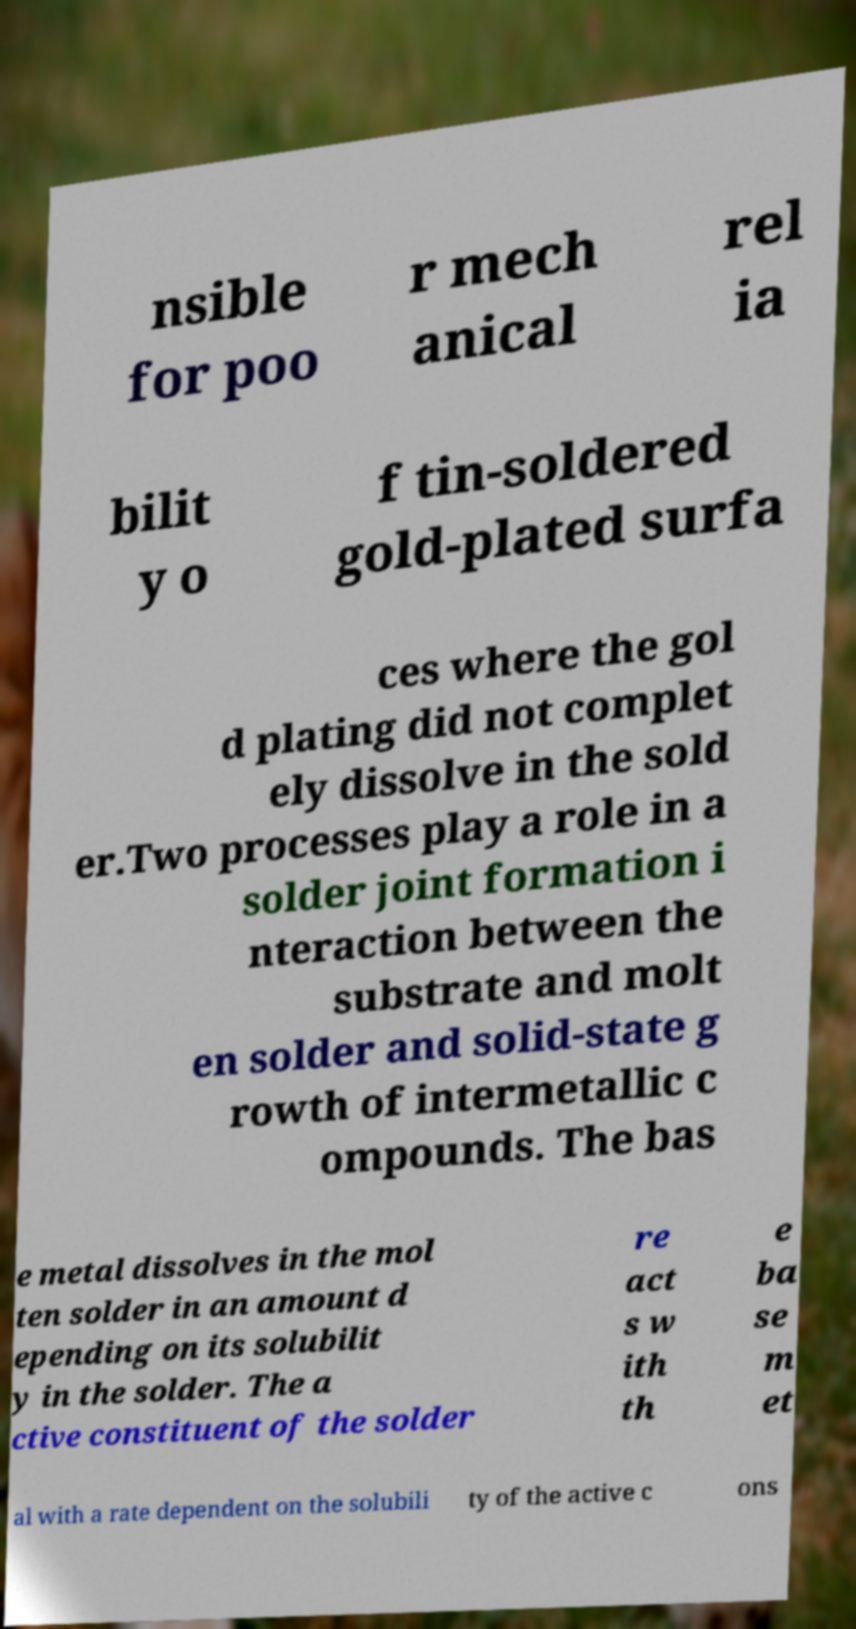Could you assist in decoding the text presented in this image and type it out clearly? nsible for poo r mech anical rel ia bilit y o f tin-soldered gold-plated surfa ces where the gol d plating did not complet ely dissolve in the sold er.Two processes play a role in a solder joint formation i nteraction between the substrate and molt en solder and solid-state g rowth of intermetallic c ompounds. The bas e metal dissolves in the mol ten solder in an amount d epending on its solubilit y in the solder. The a ctive constituent of the solder re act s w ith th e ba se m et al with a rate dependent on the solubili ty of the active c ons 